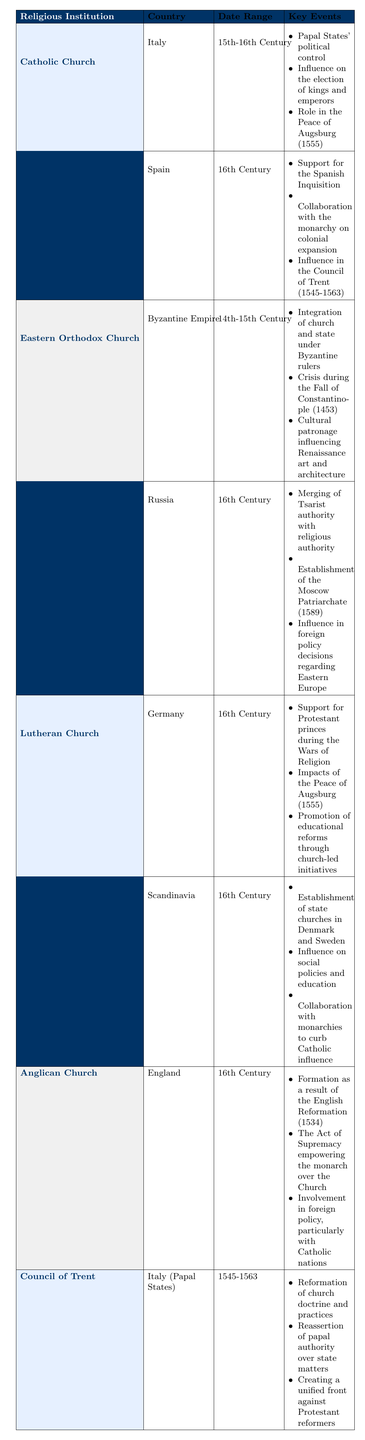What countries were influenced by the Catholic Church during the 16th Century? The table indicates that the Catholic Church influenced Spain during the 16th Century, as noted in the entry under that country.
Answer: Spain Which religious institution had an impact on the Byzantine Empire in the 14th-15th Century? According to the table, the Eastern Orthodox Church was active in the Byzantine Empire during that period.
Answer: Eastern Orthodox Church True or False: The Anglican Church was influential in Germany in the 16th Century. The table does not list the Anglican Church as having any influence on Germany, so the statement is false.
Answer: False What was one key event associated with the Council of Trent? The table lists several key events, one of which is the reformation of church doctrine and practices, which is specific to the Council of Trent.
Answer: Reformation of church doctrine and practices How many key events are listed for the Catholic Church's influence in Spain? There are three key events listed under the Catholic Church's influence in Spain, as per the table.
Answer: 3 Which religious institutions were involved in influencing state affairs in Russia during the 16th Century? The table specifies that the Eastern Orthodox Church was the religious institution influencing state affairs in Russia during the 16th Century.
Answer: Eastern Orthodox Church What significant change regarding church authority was established in Russia in 1589? The table reveals that the establishment of the Moscow Patriarchate in 1589 marked a merging of Tsarist and religious authority in Russia.
Answer: Establishment of the Moscow Patriarchate What were the date ranges for the Catholic Church's influence in Italy? The table indicates that the date range for the Catholic Church's influence in Italy is the 15th to 16th Century.
Answer: 15th-16th Century True or False: The Lutheran Church established a state church in Russia during the 16th Century. The table does not mention the Lutheran Church's establishment of a state church in Russia. Instead, it states that Lutheran influence was in Germany and Scandinavia. Therefore, the statement is false.
Answer: False 